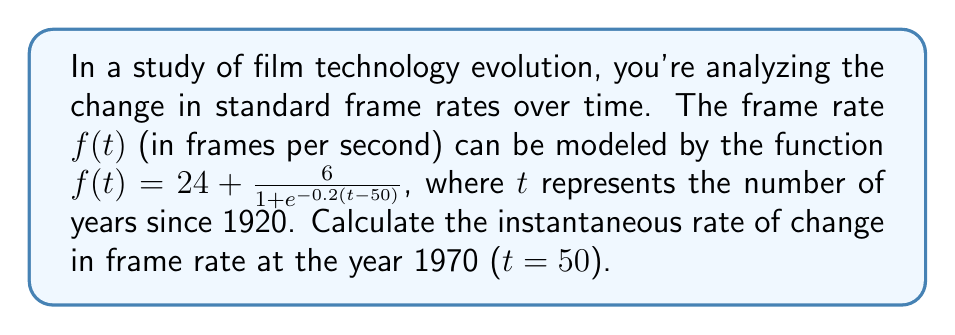Help me with this question. To find the instantaneous rate of change at a specific point, we need to calculate the derivative of the function and evaluate it at the given point. Let's break this down step-by-step:

1) The given function is:
   $$f(t) = 24 + \frac{6}{1 + e^{-0.2(t-50)}}$$

2) To find the derivative, we'll use the chain rule. Let's set $u = -0.2(t-50)$ for simplicity.
   $$f(t) = 24 + 6(1 + e^u)^{-1}$$

3) Applying the chain rule:
   $$\frac{df}{dt} = 0 + 6 \cdot (-1)(1 + e^u)^{-2} \cdot e^u \cdot \frac{du}{dt}$$

4) We know that $\frac{du}{dt} = -0.2$, so:
   $$\frac{df}{dt} = -6 \cdot \frac{e^u}{(1 + e^u)^2} \cdot (-0.2)$$

5) Simplifying:
   $$\frac{df}{dt} = \frac{1.2e^u}{(1 + e^u)^2}$$

6) Now, we need to evaluate this at t = 50. When t = 50, u = -0.2(50-50) = 0.
   $$\left.\frac{df}{dt}\right|_{t=50} = \frac{1.2e^0}{(1 + e^0)^2} = \frac{1.2}{(1 + 1)^2} = \frac{1.2}{4} = 0.3$$

Therefore, the instantaneous rate of change in frame rate at t = 50 (year 1970) is 0.3 frames per second per year.
Answer: 0.3 frames per second per year 